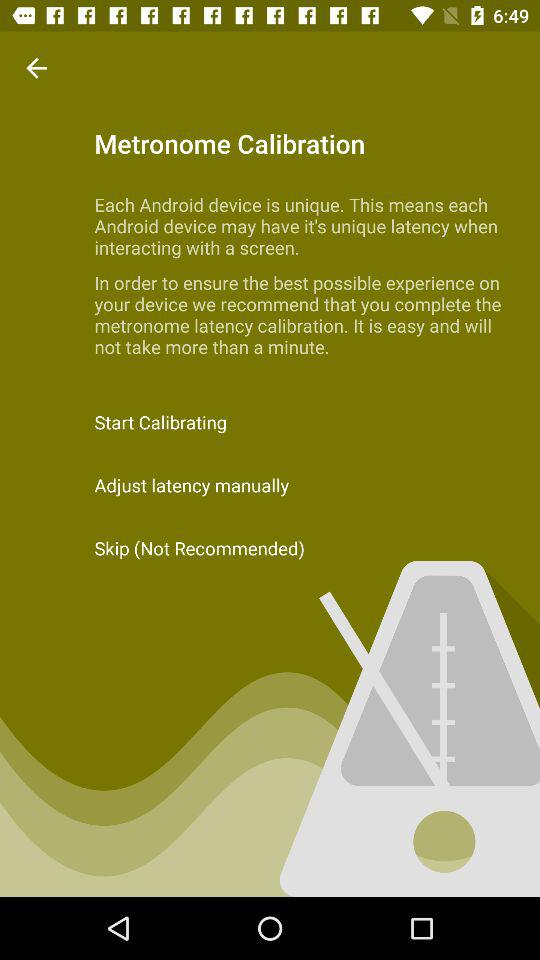How many options are there to calibrate latency?
Answer the question using a single word or phrase. 3 